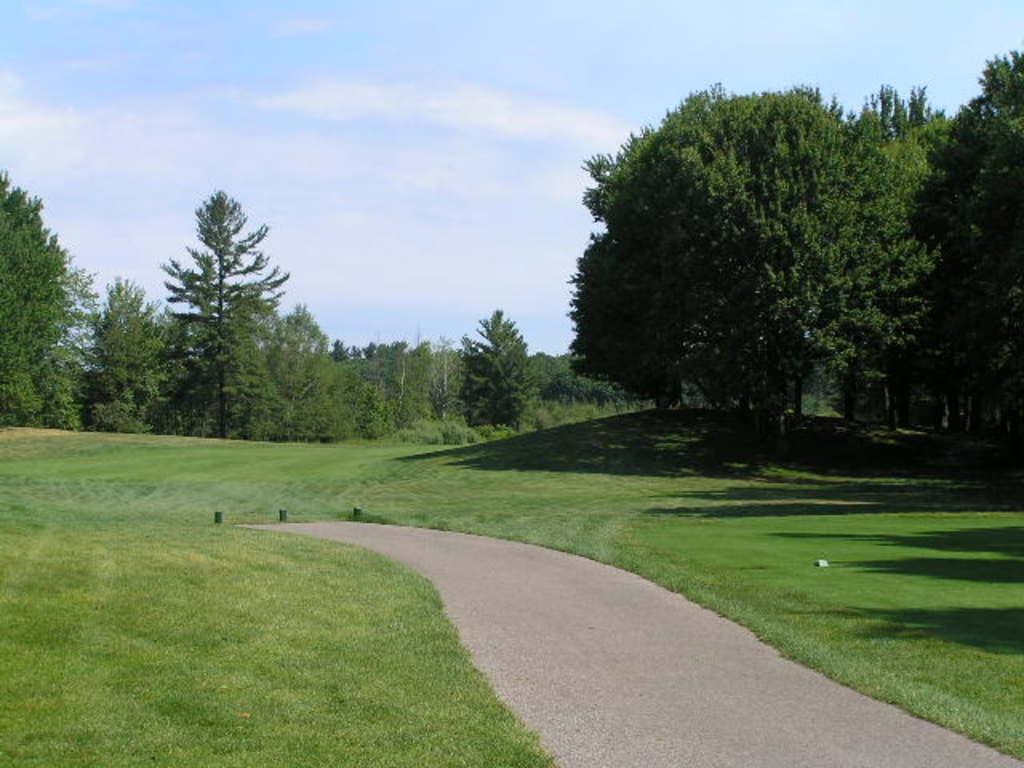What is the main feature of the image? There is a path in the image. What can be seen on either side of the path? There are grasslands on either side of the path. What is visible in the background of the image? There are trees and the sky in the background of the image. Can you tell me how many cars are driving on the path in the image? There are no cars or any vehicles visible in the image; it only shows a path with grasslands on either side and trees and sky in the background. 